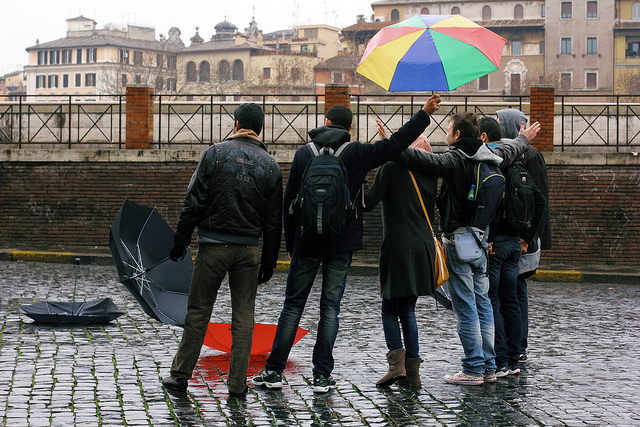Can you describe the mood or atmosphere of this scene? The scene conveys a sense of camaraderie and resilience in the face of inclement weather. There's an umbrella shared among friends, and despite the gloomy weather, the group's closeness hints at a warm, collective spirit. 